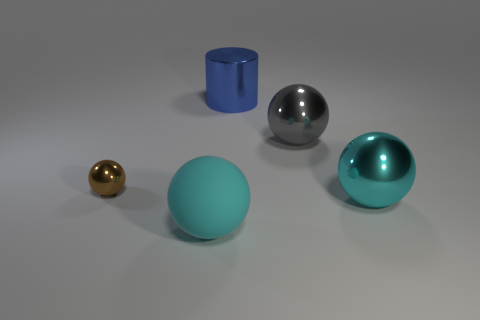Subtract 1 spheres. How many spheres are left? 3 Add 4 yellow spheres. How many objects exist? 9 Subtract all balls. How many objects are left? 1 Add 5 brown spheres. How many brown spheres are left? 6 Add 4 large blue shiny cylinders. How many large blue shiny cylinders exist? 5 Subtract 0 gray blocks. How many objects are left? 5 Subtract all blue metallic cylinders. Subtract all gray objects. How many objects are left? 3 